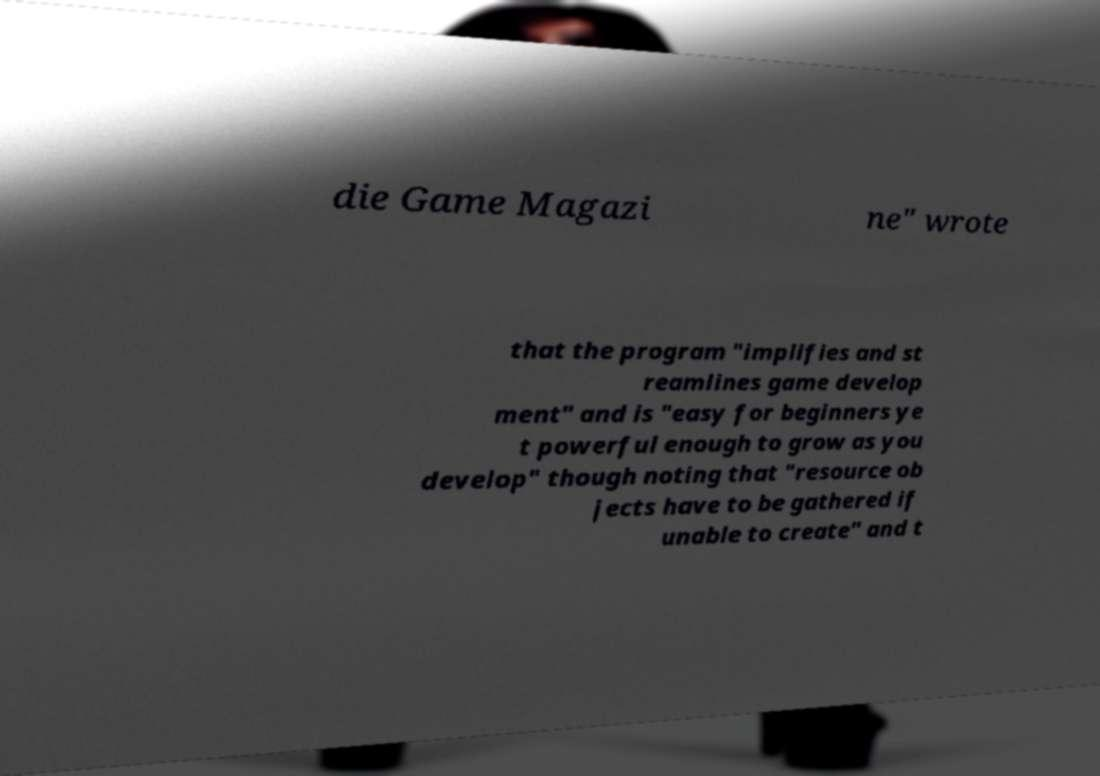Can you accurately transcribe the text from the provided image for me? die Game Magazi ne" wrote that the program "implifies and st reamlines game develop ment" and is "easy for beginners ye t powerful enough to grow as you develop" though noting that "resource ob jects have to be gathered if unable to create" and t 